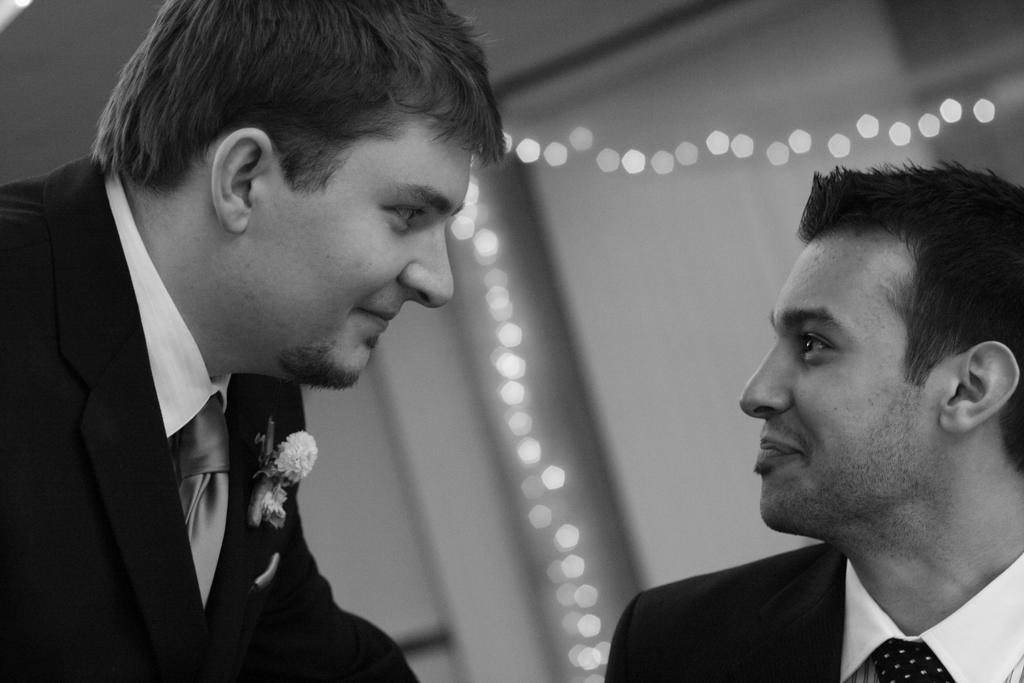In one or two sentences, can you explain what this image depicts? This is a black and white image, in this image there are two men, in the background there is a wall to that wall there is a lighting. 